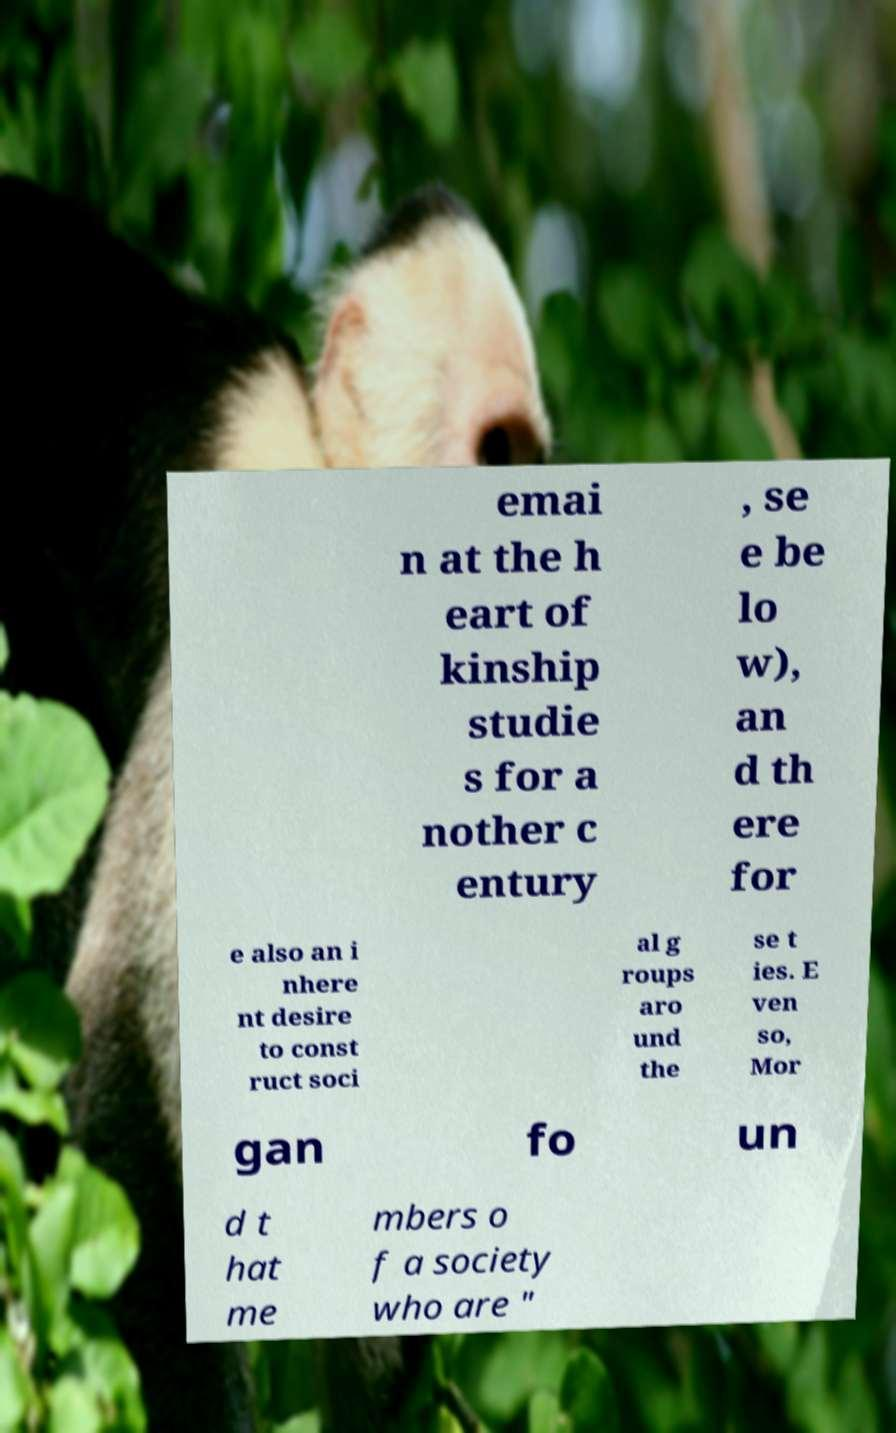Could you extract and type out the text from this image? emai n at the h eart of kinship studie s for a nother c entury , se e be lo w), an d th ere for e also an i nhere nt desire to const ruct soci al g roups aro und the se t ies. E ven so, Mor gan fo un d t hat me mbers o f a society who are " 